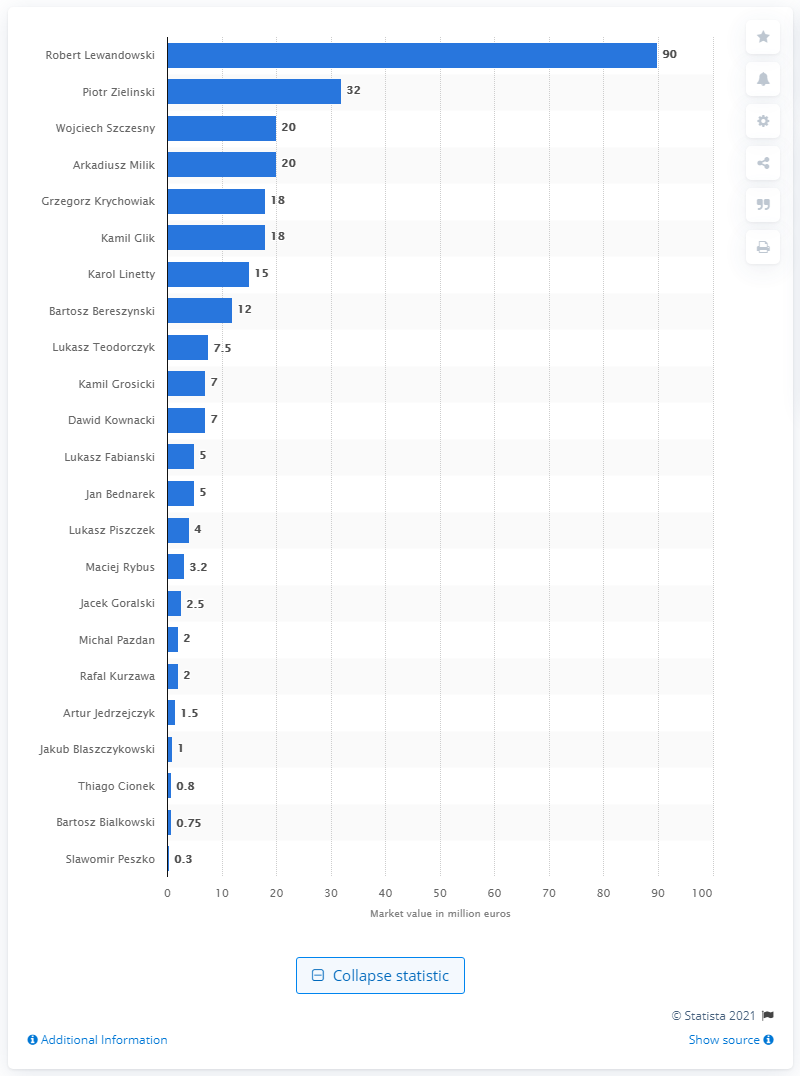List a handful of essential elements in this visual. The most valuable player at the 2018 FIFA World Cup was Robert Lewandowski. Robert Lewandowski's market value was estimated to be around 90 million dollars. 